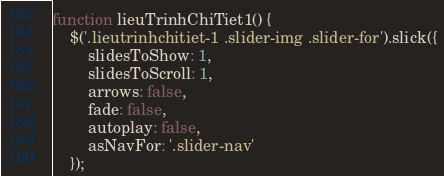Convert code to text. <code><loc_0><loc_0><loc_500><loc_500><_JavaScript_>function lieuTrinhChiTiet1() {
	$('.lieutrinhchitiet-1 .slider-img .slider-for').slick({
		slidesToShow: 1,
		slidesToScroll: 1,
		arrows: false,
		fade: false,
		autoplay: false,
		asNavFor: '.slider-nav'
	});</code> 